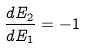<formula> <loc_0><loc_0><loc_500><loc_500>\frac { d E _ { 2 } } { d E _ { 1 } } = - 1</formula> 